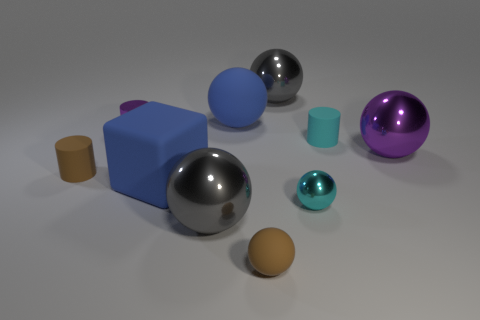Subtract all cyan spheres. How many spheres are left? 5 Subtract all small rubber cylinders. How many cylinders are left? 1 Subtract all cylinders. How many objects are left? 7 Subtract 1 cubes. How many cubes are left? 0 Subtract all gray cylinders. How many gray spheres are left? 2 Subtract all big purple metallic spheres. Subtract all matte blocks. How many objects are left? 8 Add 1 small brown matte cylinders. How many small brown matte cylinders are left? 2 Add 4 small purple shiny cylinders. How many small purple shiny cylinders exist? 5 Subtract 0 red spheres. How many objects are left? 10 Subtract all green spheres. Subtract all cyan cubes. How many spheres are left? 6 